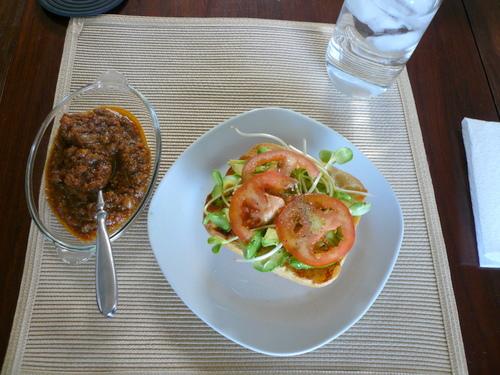How many plates are there?
Answer briefly. 1. Is a placemat being used?
Be succinct. Yes. Are these salads?
Quick response, please. No. Which of these dishes contains the most vegetables?
Short answer required. Right. Is there rice on the plate?
Keep it brief. No. Are there tomatoes on this sandwich?
Quick response, please. Yes. How many people will be eating?
Give a very brief answer. 1. How many plates of food?
Concise answer only. 1. 